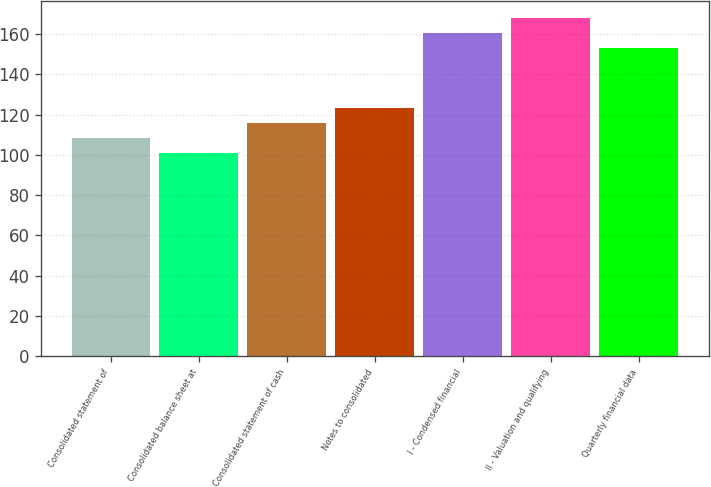Convert chart to OTSL. <chart><loc_0><loc_0><loc_500><loc_500><bar_chart><fcel>Consolidated statement of<fcel>Consolidated balance sheet at<fcel>Consolidated statement of cash<fcel>Notes to consolidated<fcel>I - Condensed financial<fcel>II - Valuation and qualifying<fcel>Quarterly financial data<nl><fcel>108.5<fcel>101<fcel>116<fcel>123.5<fcel>160.5<fcel>168<fcel>153<nl></chart> 